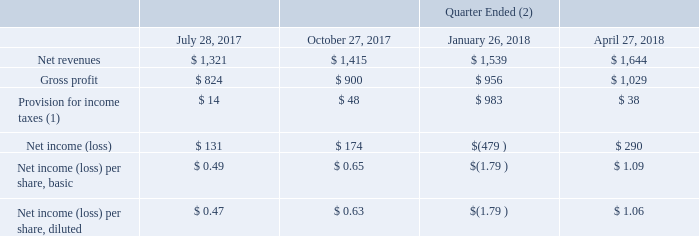Selected Quarterly Financial Data (Unaudited)
Selected quarterly financial data is as follows (in millions, except per share amounts):
(1) In the quarter ended January 26, 2018, our provision for income taxes included significant charges attributable to United States tax reform.
(2) The quarters of fiscal 2018 have been adjusted for our retrospective adoption of the new accounting standard Revenue from Contracts with Customers (ASC 606).
What did the provision for income taxes in the quarter ended January 26, 2018 include? Significant charges attributable to united states tax reform. How have the quarters of fiscal 2018 been adjusted? For our retrospective adoption of the new accounting standard revenue from contracts with customers (asc 606). What was the net revenue for the quarter of July 28, 2017?
Answer scale should be: million. 1,321. What was the change in the gross profit between the quarters of January 26 and April 27, 2018?
Answer scale should be: million. 1,029-956
Answer: 73. What was the sum of the net revenues from the last two quarters?
Answer scale should be: million. 1,539+1,644
Answer: 3183. What was the percentage change in Net income (loss) between July 28, 2017 and October 27, 2017?
Answer scale should be: percent. (174-131)/131
Answer: 32.82. 